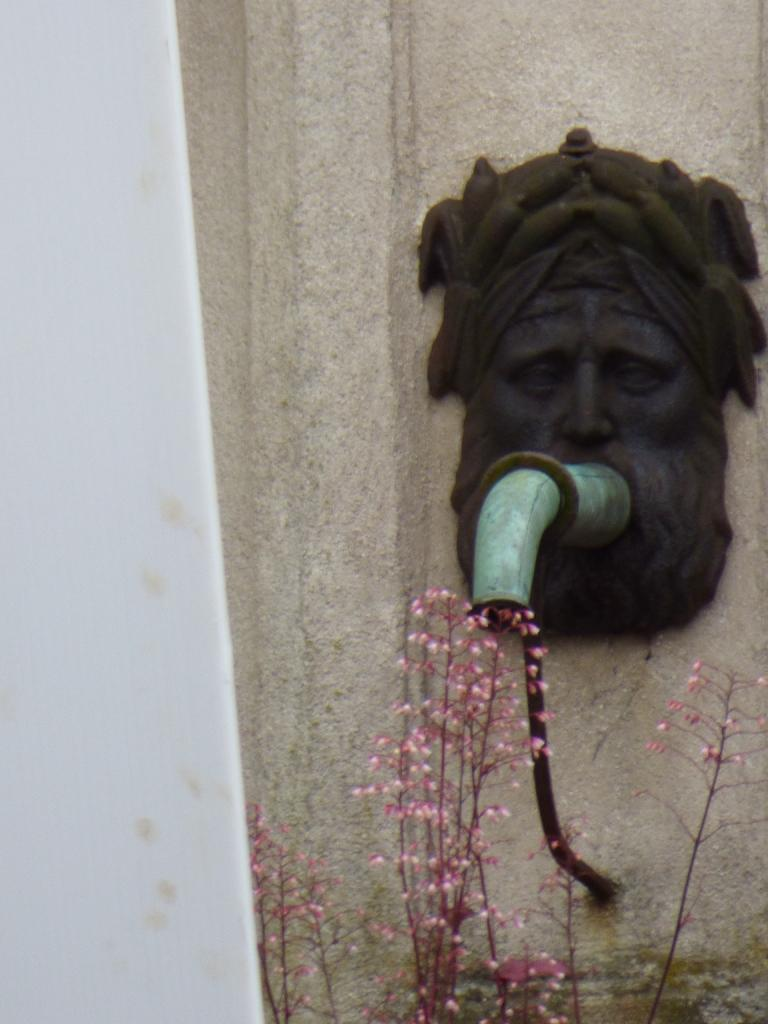What type of structure can be seen in the image? There is a wall in the image. What artistic element is present in the image? There is a sculpture in the image. What type of plumbing fixture is visible in the image? There is a pipe in the image. What type of plant is present in the image? There is a flower plant in the image. Can you describe any other objects in the image? There are unspecified objects in the image. What type of powder is being used for digestion in the image? There is no powder or digestion process depicted in the image. Can you tell me how many aunts are present in the image? There are no people, including aunts, present in the image. 